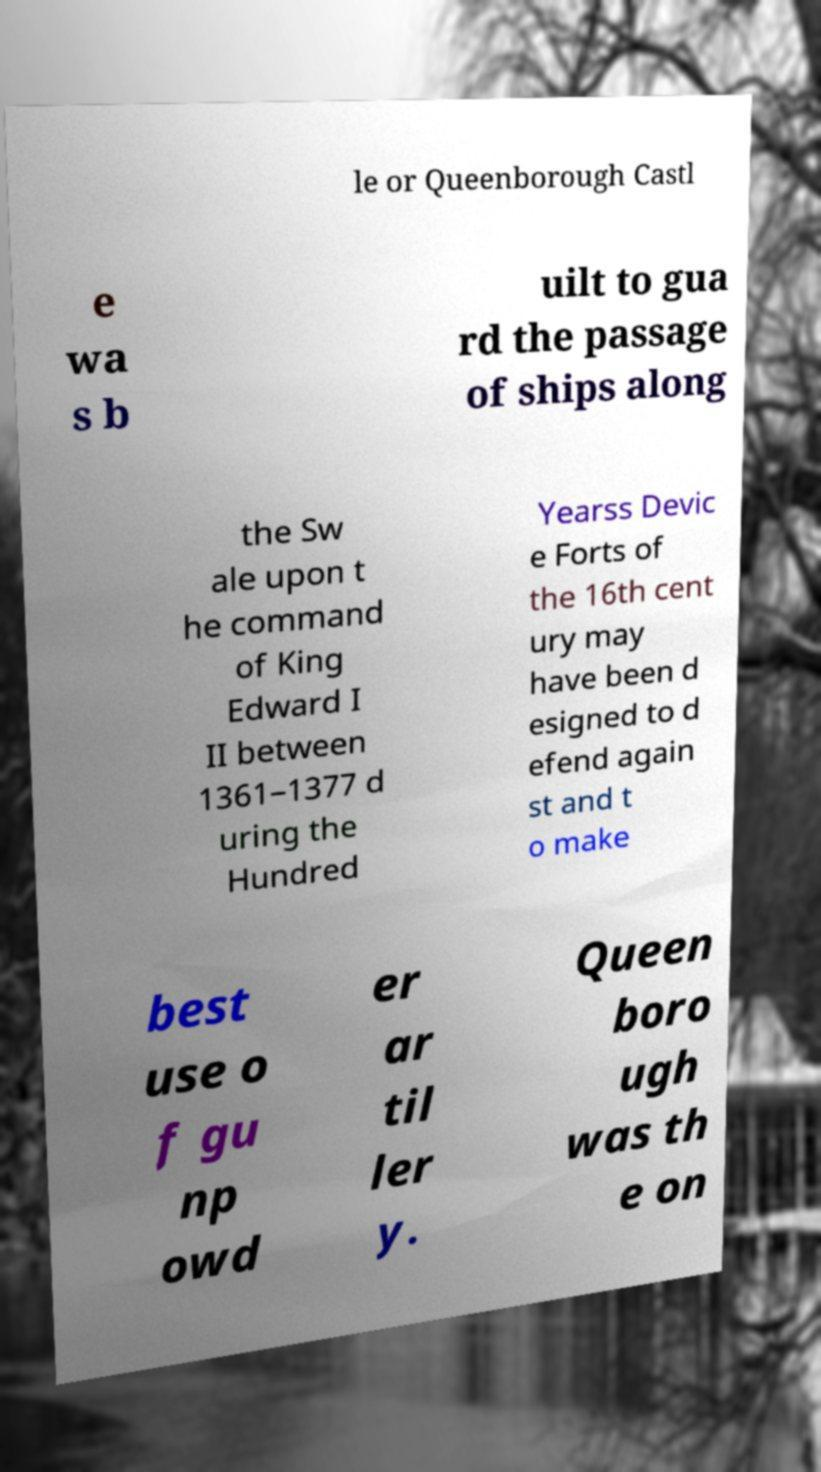Could you assist in decoding the text presented in this image and type it out clearly? le or Queenborough Castl e wa s b uilt to gua rd the passage of ships along the Sw ale upon t he command of King Edward I II between 1361–1377 d uring the Hundred Yearss Devic e Forts of the 16th cent ury may have been d esigned to d efend again st and t o make best use o f gu np owd er ar til ler y. Queen boro ugh was th e on 